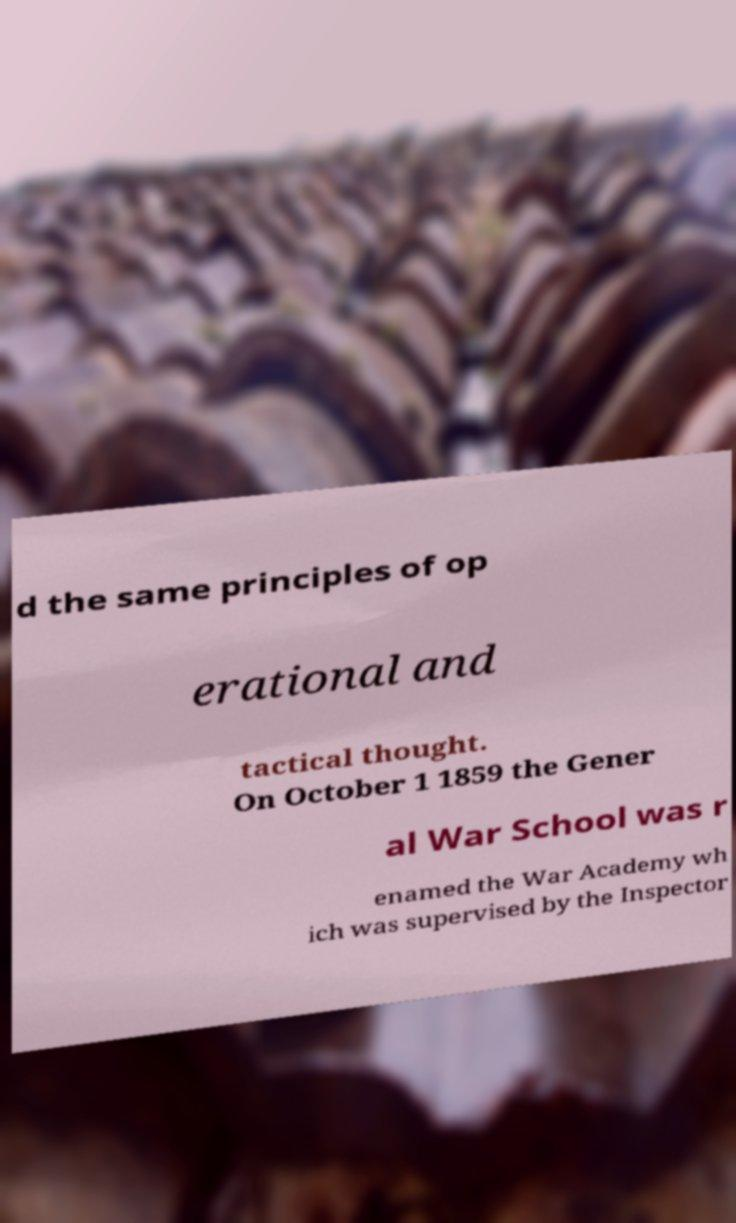Can you accurately transcribe the text from the provided image for me? d the same principles of op erational and tactical thought. On October 1 1859 the Gener al War School was r enamed the War Academy wh ich was supervised by the Inspector 